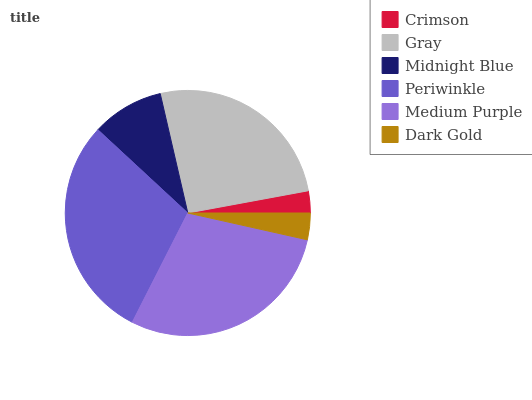Is Crimson the minimum?
Answer yes or no. Yes. Is Periwinkle the maximum?
Answer yes or no. Yes. Is Gray the minimum?
Answer yes or no. No. Is Gray the maximum?
Answer yes or no. No. Is Gray greater than Crimson?
Answer yes or no. Yes. Is Crimson less than Gray?
Answer yes or no. Yes. Is Crimson greater than Gray?
Answer yes or no. No. Is Gray less than Crimson?
Answer yes or no. No. Is Gray the high median?
Answer yes or no. Yes. Is Midnight Blue the low median?
Answer yes or no. Yes. Is Crimson the high median?
Answer yes or no. No. Is Dark Gold the low median?
Answer yes or no. No. 